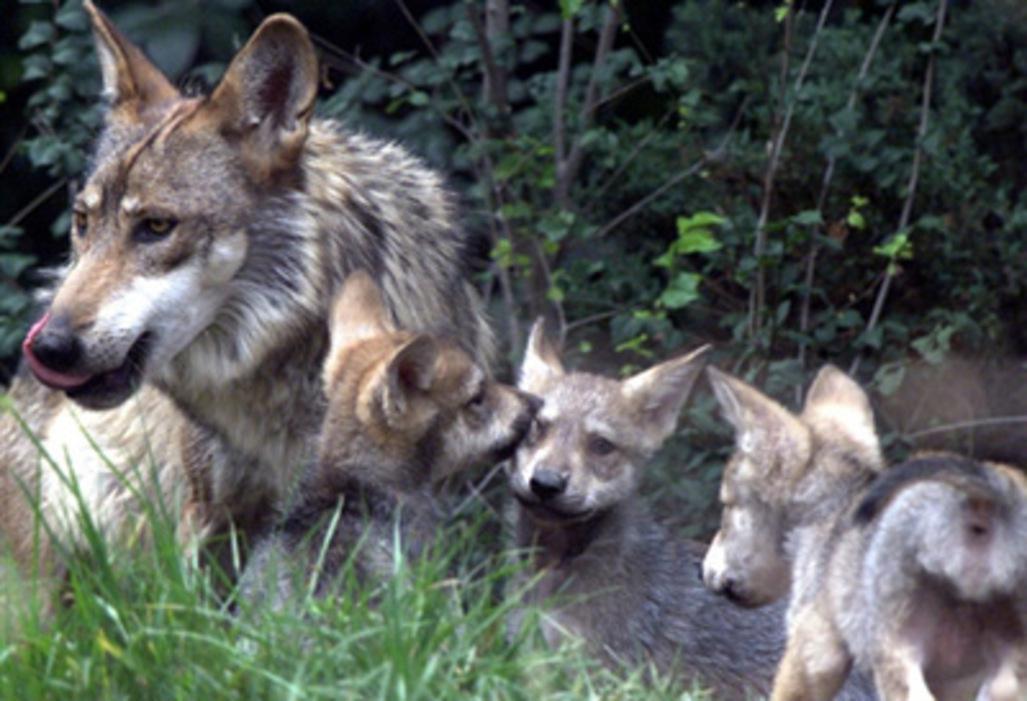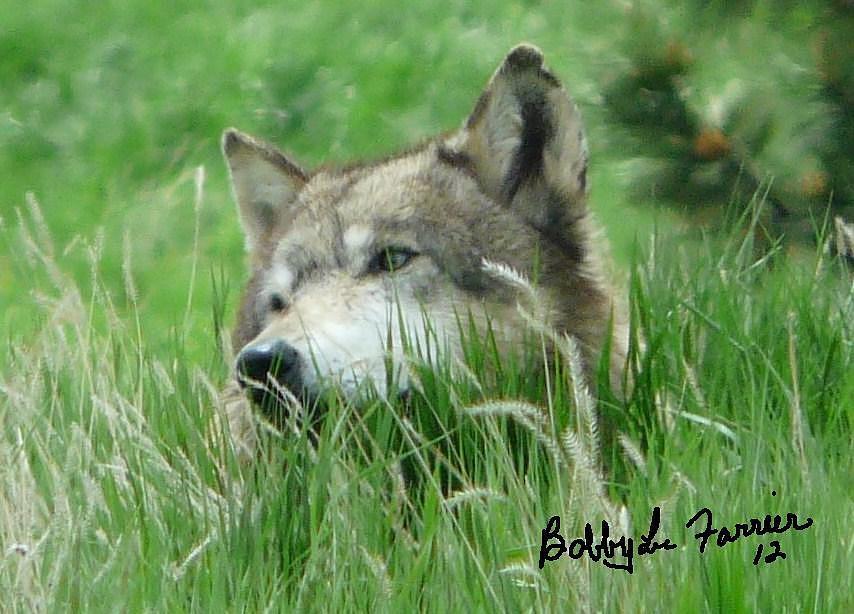The first image is the image on the left, the second image is the image on the right. For the images displayed, is the sentence "The right image contains no more than one wolf." factually correct? Answer yes or no. Yes. The first image is the image on the left, the second image is the image on the right. Analyze the images presented: Is the assertion "There are five wolves in total." valid? Answer yes or no. Yes. 